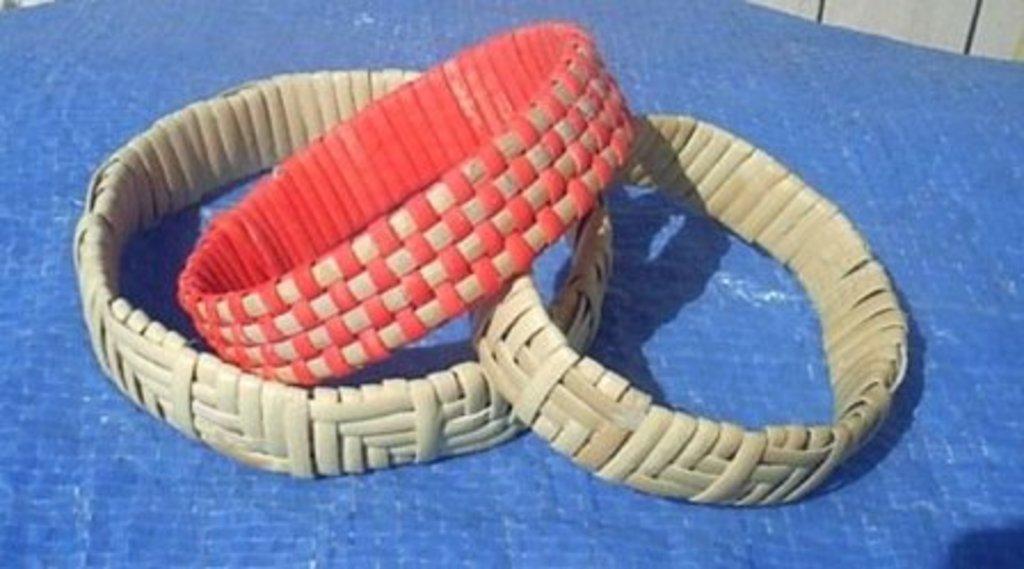How would you summarize this image in a sentence or two? In this picture, it seems to be there are hand bracelets in the image. 